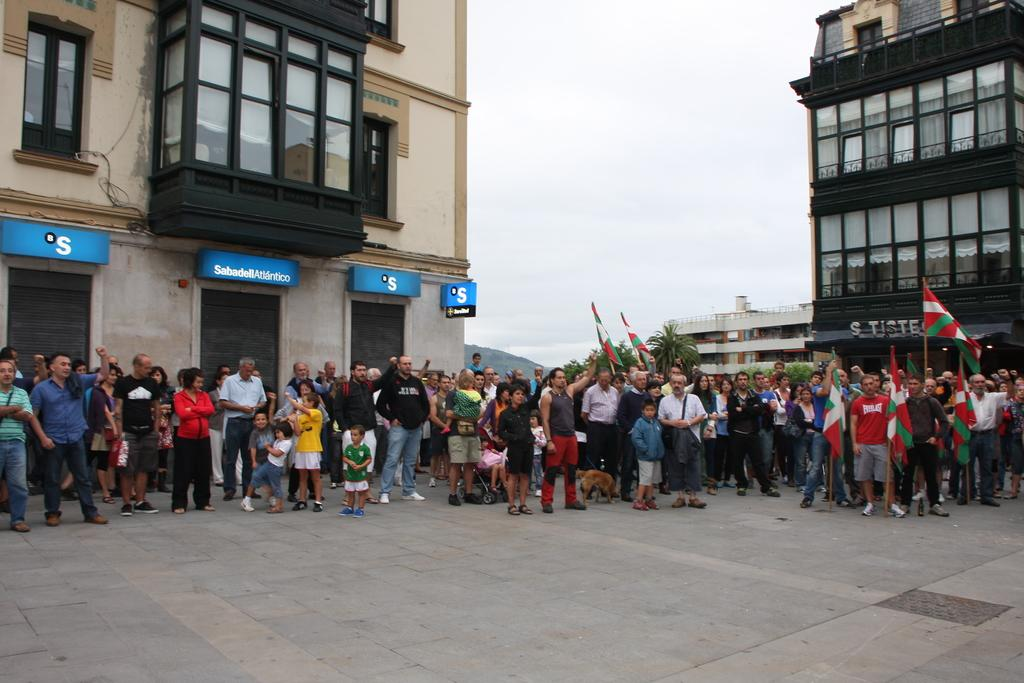How many people are in the group in the image? There is a group of people in the image, but the exact number is not specified. What are some people in the group holding? Some people in the group are holding flags. What can be seen in the background of the image? There are buildings, hoardings, and trees visible in the background of the image. Can you tell me how many worms are crawling on the person in the image? There are no worms present in the image, and no person is mentioned as having worms on them. 